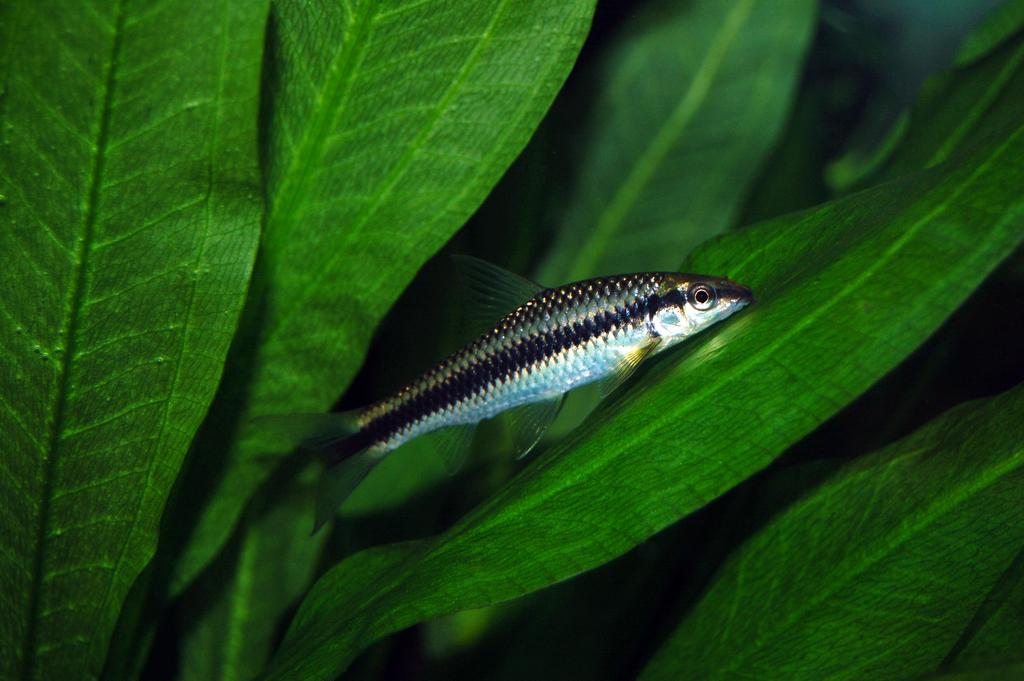What type of animal is present in the image? There is a fish in the image. What can be seen in the background behind the fish? There are leaves visible behind the fish in the image. How many ants are crawling on the fish in the image? There are no ants present in the image; it only features a fish and leaves in the background. 